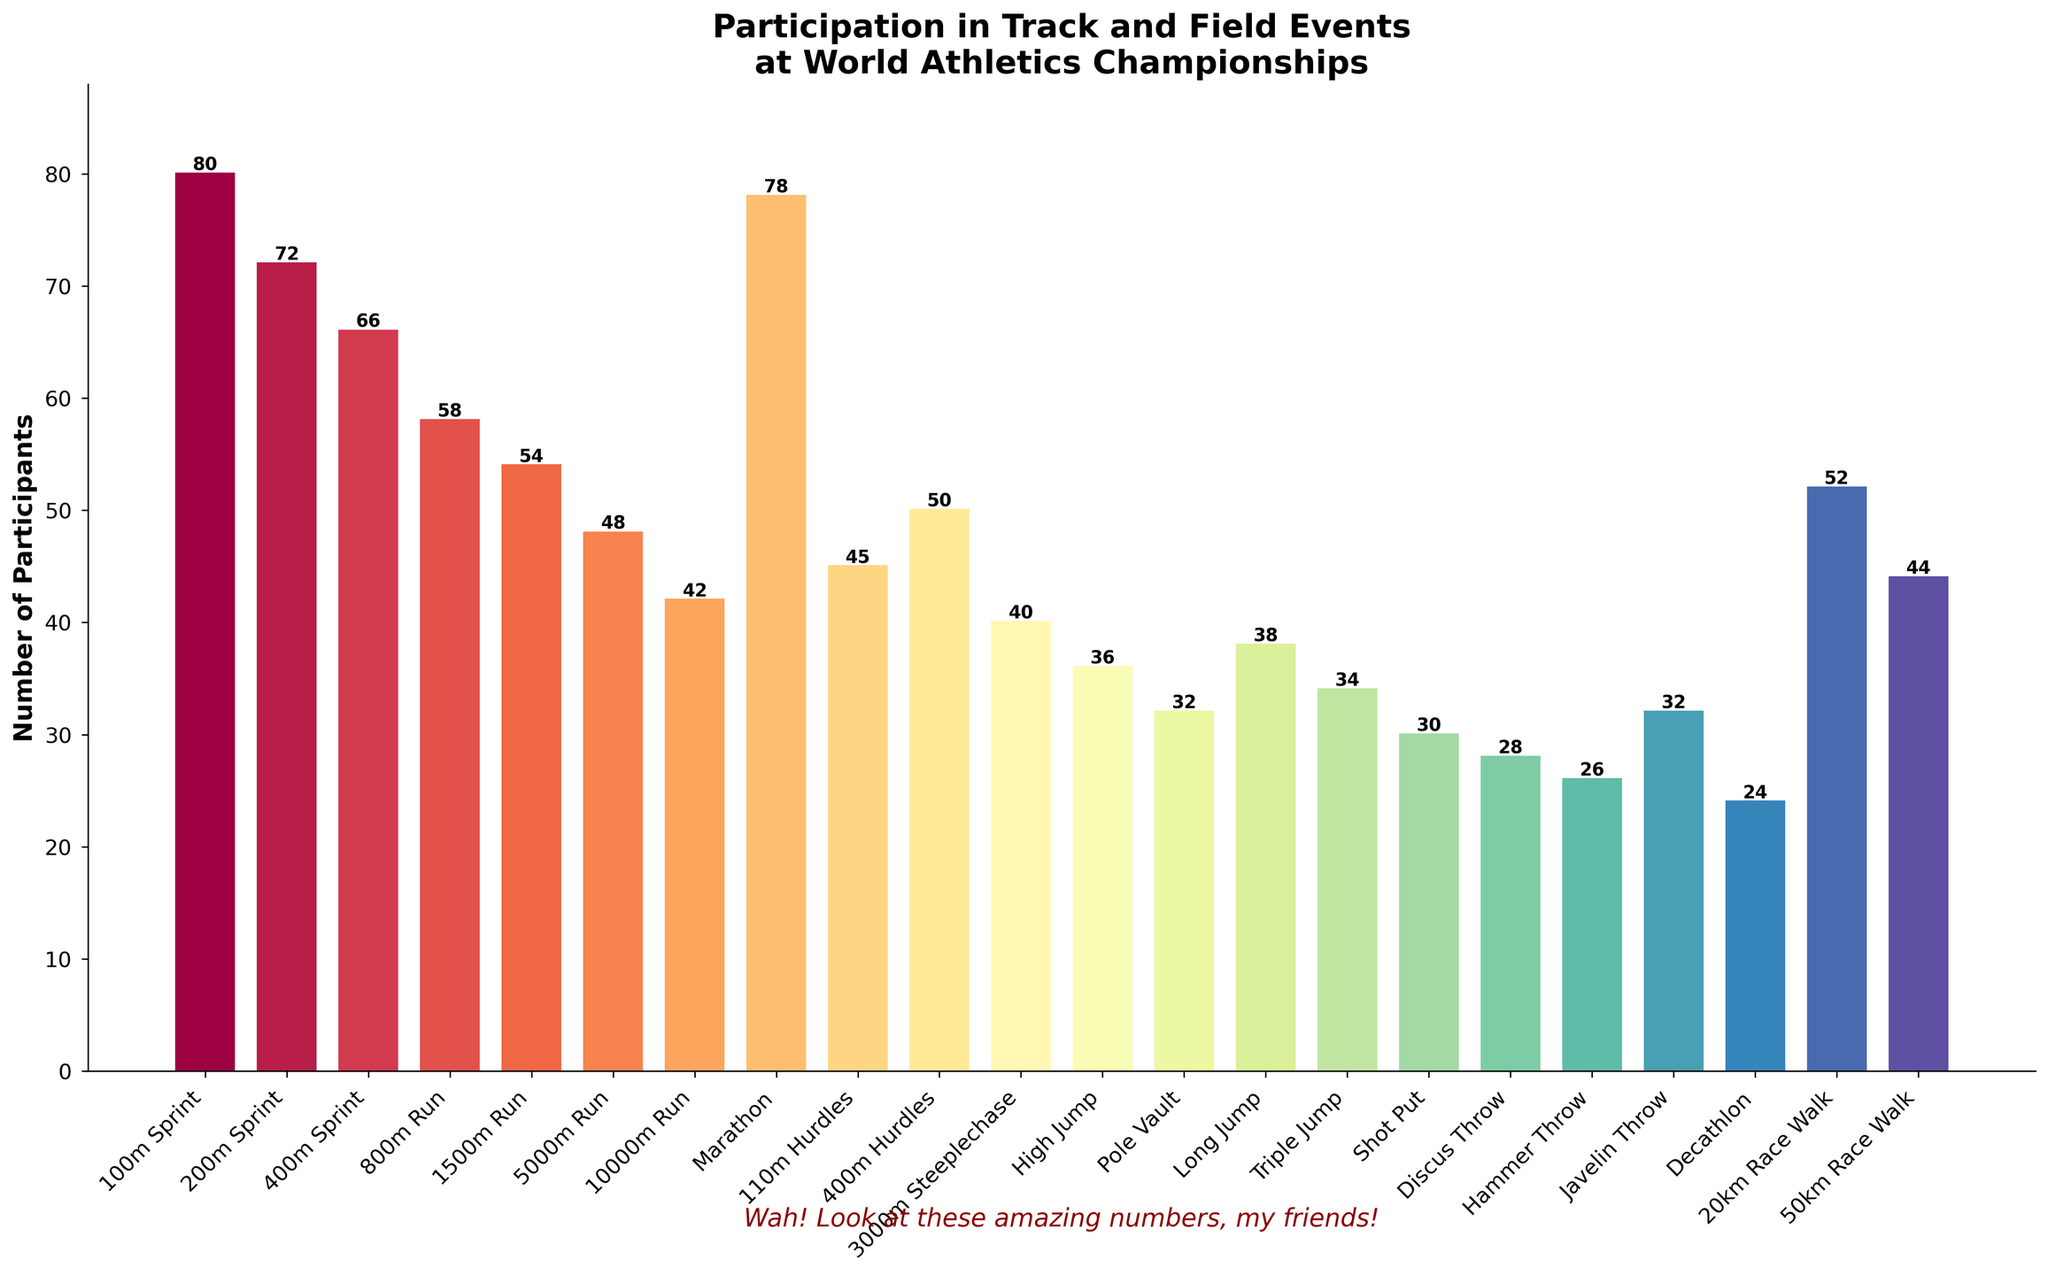What's the event with the most participants? Locate the tallest bar in the chart. The tallest bar represents the 100m Sprint with 80 participants.
Answer: 100m Sprint Which events have fewer than 40 participants? Identify the bars with heights less than 40 on the vertical axis. These events are High Jump, Pole Vault, Triple Jump, Shot Put, Discus Throw, Hammer Throw, Javelin Throw, and Decathlon.
Answer: High Jump, Pole Vault, Triple Jump, Shot Put, Discus Throw, Hammer Throw, Javelin Throw, Decathlon What is the difference in participant numbers between the Marathon and the 5000m Run? Find the heights of the bars for the Marathon and the 5000m Run. Marathon has 78 participants and the 5000m Run has 48 participants. The difference is 78 - 48 = 30.
Answer: 30 How do the participant numbers for the 200m Sprint and the 110m Hurdles compare? Check the heights of the bars for the 200m Sprint and the 110m Hurdles. The 200m Sprint has 72 participants, and the 110m Hurdles has 45 participants. The 200m Sprint has more participants.
Answer: 200m Sprint has more Which events have an equal number of participants? Look for bars of the same height. The Pole Vault and the Javelin Throw both have 32 participants.
Answer: Pole Vault, Javelin Throw What is the average number of participants in the Sprints (100m, 200m, 400m)? Sum the participants in the 100m Sprint (80), 200m Sprint (72), and 400m Sprint (66), which equals 218. Divide by 3. The average is 218 / 3 = 72.67.
Answer: 72.67 Are there more participants in the Marathon or the 1500m Run? Compare the heights of the bars for the Marathon and the 1500m Run. The Marathon bar is taller with 78 participants compared to the 1500m Run's 54 participants.
Answer: Marathon What’s the combined number of participants in all throwing events (Shot Put, Discus Throw, Hammer Throw, Javelin Throw)? Sum the participants in the Shot Put (30), Discus Throw (28), Hammer Throw (26), and Javelin Throw (32). The total is 30 + 28 + 26 + 32 = 116.
Answer: 116 Which event has the least participants and how many does it have? Find the shortest bar on the chart. The Decathlon has the fewest participants with 24.
Answer: Decathlon with 24 participants 